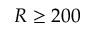Convert formula to latex. <formula><loc_0><loc_0><loc_500><loc_500>R \geq 2 0 0</formula> 